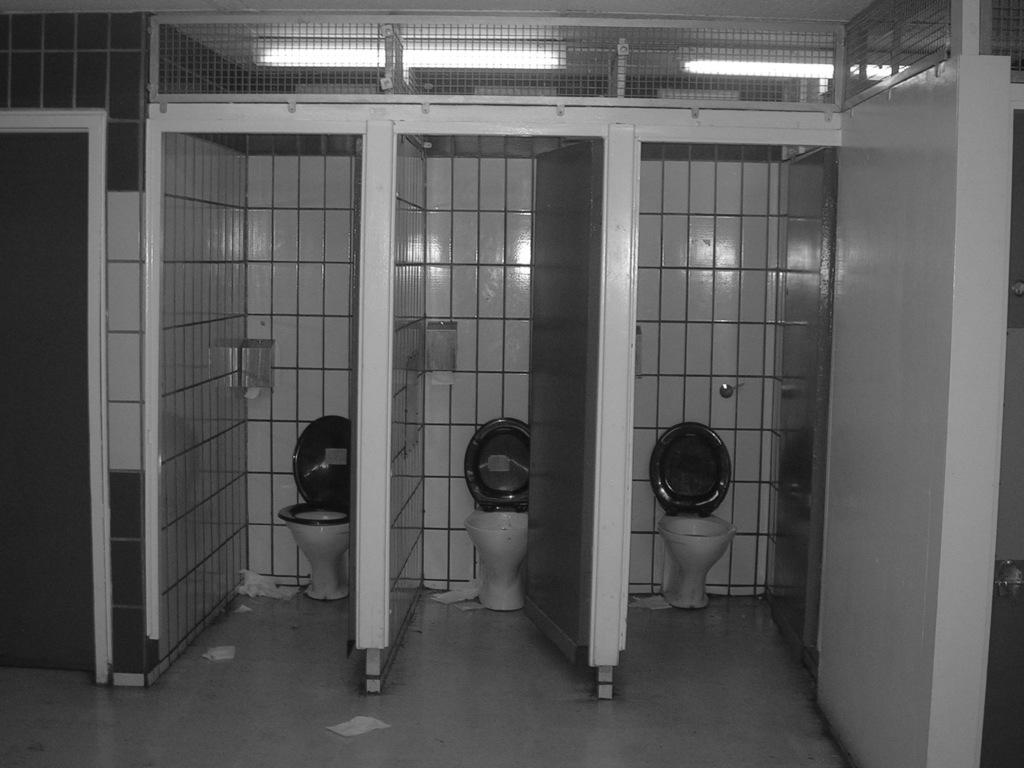Describe this image in one or two sentences. This picture shows an inner view of a restroom and we see few toilet seats and we see doors. 